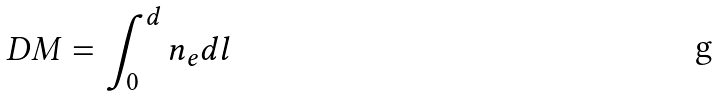Convert formula to latex. <formula><loc_0><loc_0><loc_500><loc_500>D M = \int _ { 0 } ^ { d } n _ { e } d l</formula> 